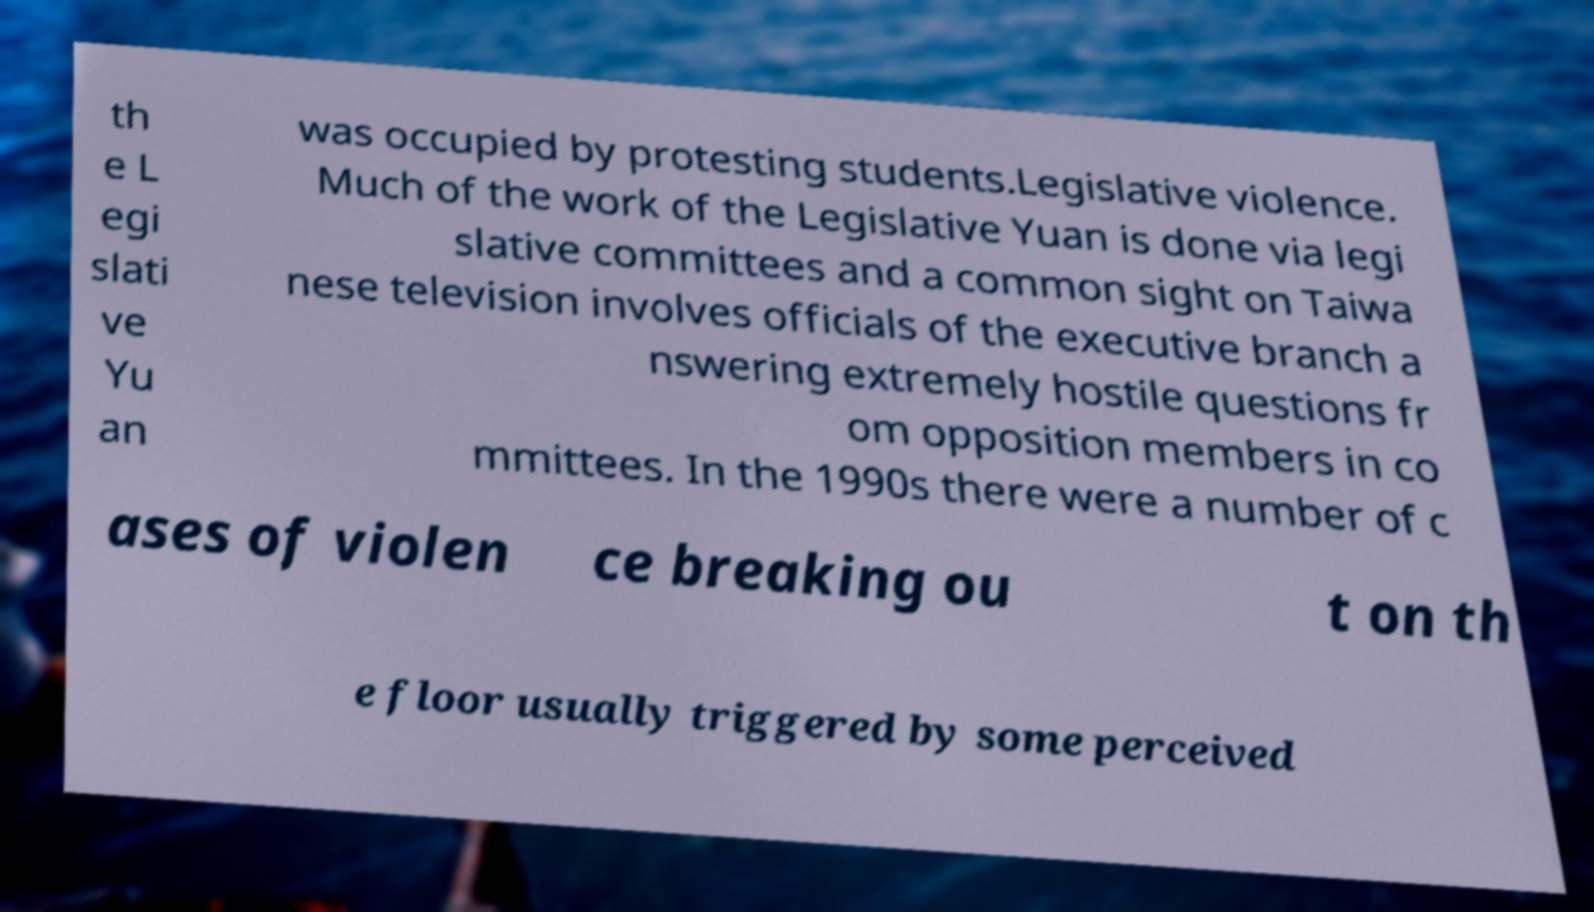Please read and relay the text visible in this image. What does it say? th e L egi slati ve Yu an was occupied by protesting students.Legislative violence. Much of the work of the Legislative Yuan is done via legi slative committees and a common sight on Taiwa nese television involves officials of the executive branch a nswering extremely hostile questions fr om opposition members in co mmittees. In the 1990s there were a number of c ases of violen ce breaking ou t on th e floor usually triggered by some perceived 